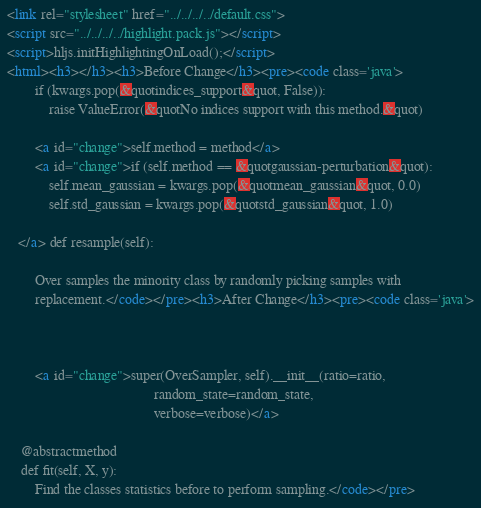<code> <loc_0><loc_0><loc_500><loc_500><_HTML_><link rel="stylesheet" href="../../../../default.css">
<script src="../../../../highlight.pack.js"></script> 
<script>hljs.initHighlightingOnLoad();</script>
<html><h3></h3><h3>Before Change</h3><pre><code class='java'>
        if (kwargs.pop(&quotindices_support&quot, False)):
            raise ValueError(&quotNo indices support with this method.&quot)

        <a id="change">self.method = method</a>
        <a id="change">if (self.method == &quotgaussian-perturbation&quot):
            self.mean_gaussian = kwargs.pop(&quotmean_gaussian&quot, 0.0)
            self.std_gaussian = kwargs.pop(&quotstd_gaussian&quot, 1.0)

   </a> def resample(self):
        
        Over samples the minority class by randomly picking samples with
        replacement.</code></pre><h3>After Change</h3><pre><code class='java'>

        

        <a id="change">super(OverSampler, self).__init__(ratio=ratio,
                                          random_state=random_state,
                                          verbose=verbose)</a>

    @abstractmethod
    def fit(self, X, y):
        Find the classes statistics before to perform sampling.</code></pre></code> 